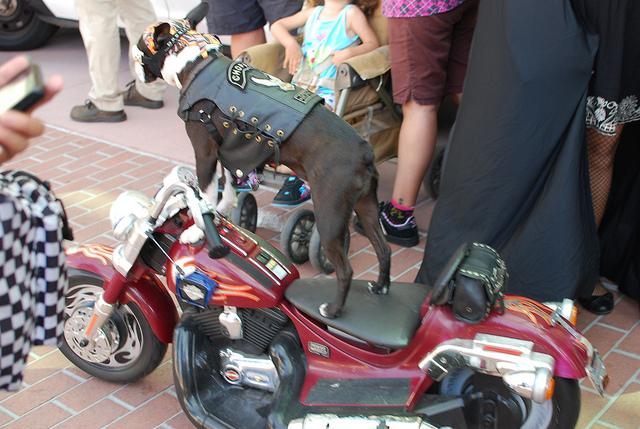What animal is depicted on the dog's jacket?
Give a very brief answer. Eagle. Is this a real motorcycle?
Keep it brief. No. How many wheels does this vehicle have?
Give a very brief answer. 2. How many cars are there out there?
Keep it brief. 0. 